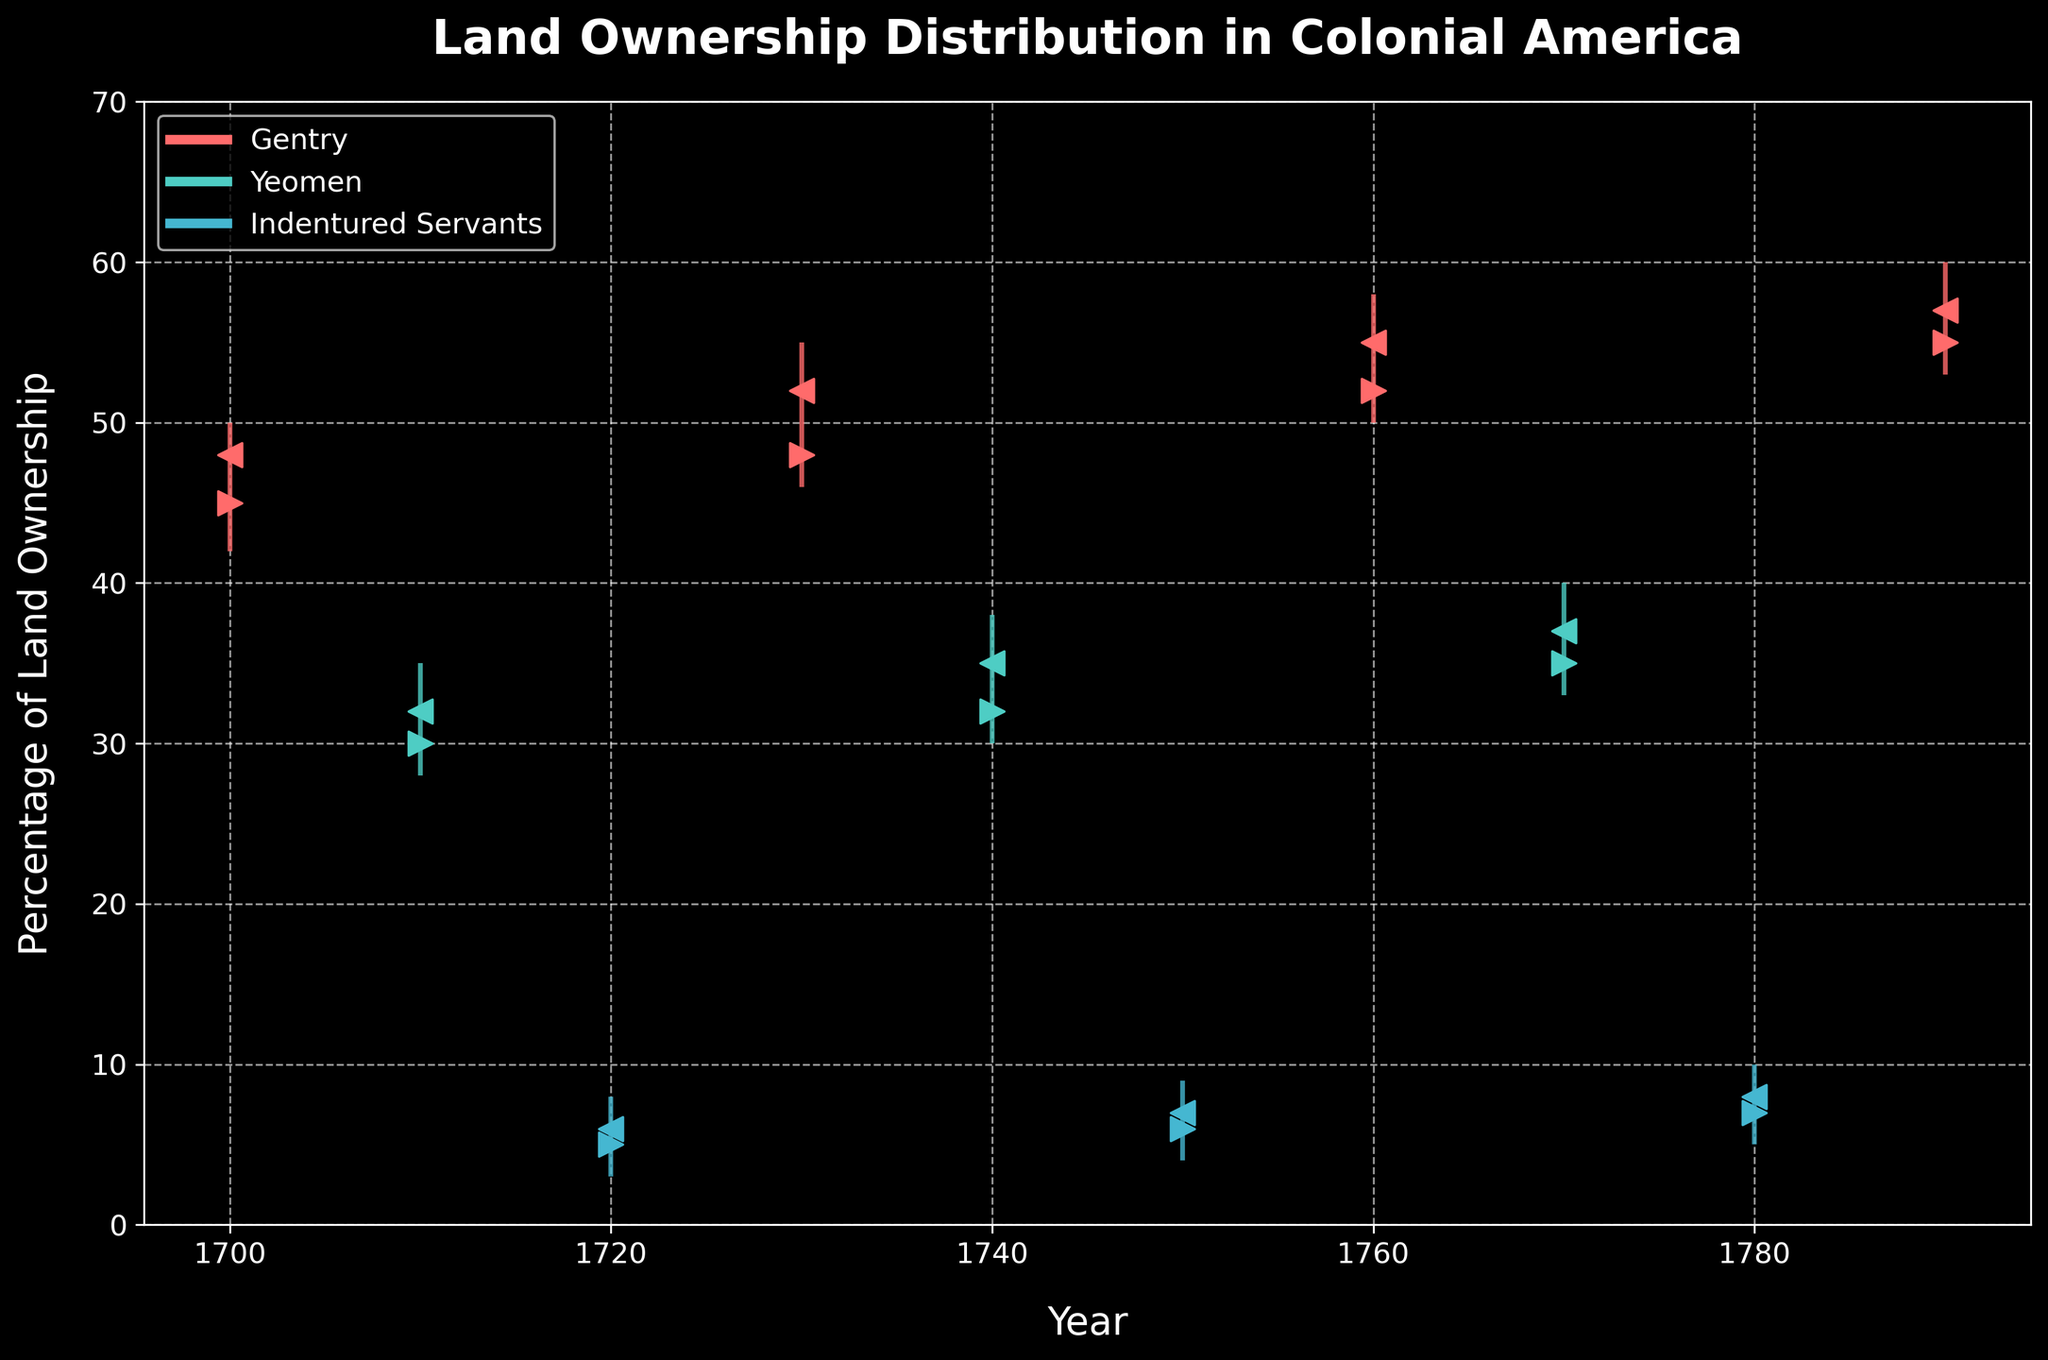What is the title of the figure? The title of the figure is written at the top and explains what the figure is about. It is a brief summary of the takeaway message.
Answer: Land Ownership Distribution in Colonial America Which class had the highest peak land ownership percentage in 1790? To find the highest peak, look at the 'High' value in 1790 for each class. The Gentry class had the highest peak land ownership percentage at 60%.
Answer: Gentry What was the difference between the opening and closing percentages for the Yeomen class in 1740? The opening value for Yeomen in 1740 was 32 while the closing value was 35. The difference is calculated by subtracting the opening from the closing: 35 - 32.
Answer: 3 Which year had the lowest minimum land ownership for the Indentured Servants class, and what was that value? To find the lowest minimum, check the 'Low' values for the Indentured Servants. The year with the lowest minimum value was 1720 with a value of 3.
Answer: 1720, 3 Between 1700 and 1790, which class exhibited the most stable (least ranged) high values, and what is the range for that class? The range is calculated as the difference between the highest 'High' and the lowest 'High' values for each class. For Gentry, the values range from 50 to 60 (range 10), Yeomen from 35 to 40 (range 5), and Indentured Servants from 8 to 10 (range 2). Therefore, Indentured Servants had the most stable high values with a range of 2.
Answer: Indentured Servants, 2 How many unique years are represented in the figure? Each unique year listed under the 'Year' column counts as one. The years shown are 1700, 1710, 1720, 1730, 1740, 1750, 1760, 1770, 1780, 1790, which totals 10 unique years.
Answer: 10 Which class shows the most significant increase in closing percentages over any decade, and what was the increase? Look at the 'Close' values for each class over each decade. The most significant increase in closing percentages happens for Yeomen from 1710 (32) to 1740 (35), an increase of 3. The Gentry: 1700 (48) to 1730 (52), increase 4. Indentured Servants: 1750 (7) to 1780 (8), increase 1. The largest increase is for the Gentry.
Answer: Gentry, 4 